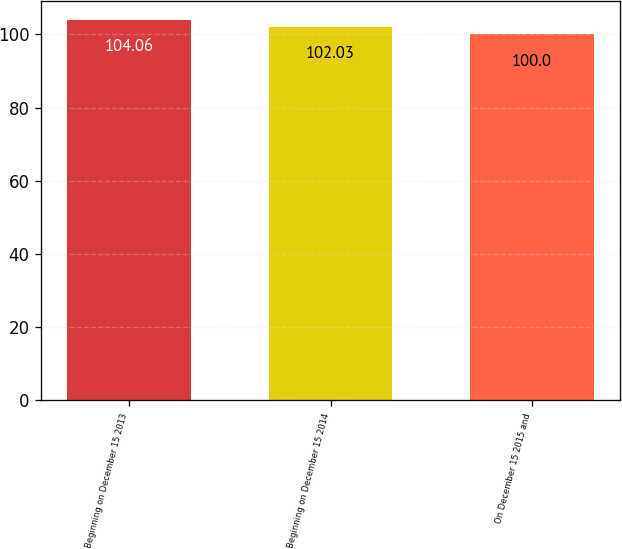Convert chart to OTSL. <chart><loc_0><loc_0><loc_500><loc_500><bar_chart><fcel>Beginning on December 15 2013<fcel>Beginning on December 15 2014<fcel>On December 15 2015 and<nl><fcel>104.06<fcel>102.03<fcel>100<nl></chart> 